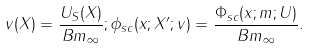<formula> <loc_0><loc_0><loc_500><loc_500>v ( X ) = \frac { U _ { S } ( X ) } { { B } m _ { \infty } } ; \phi _ { s c } ( x ; X ^ { \prime } ; v ) = \frac { \Phi _ { s c } ( x ; m ; U ) } { { B } m _ { \infty } } .</formula> 